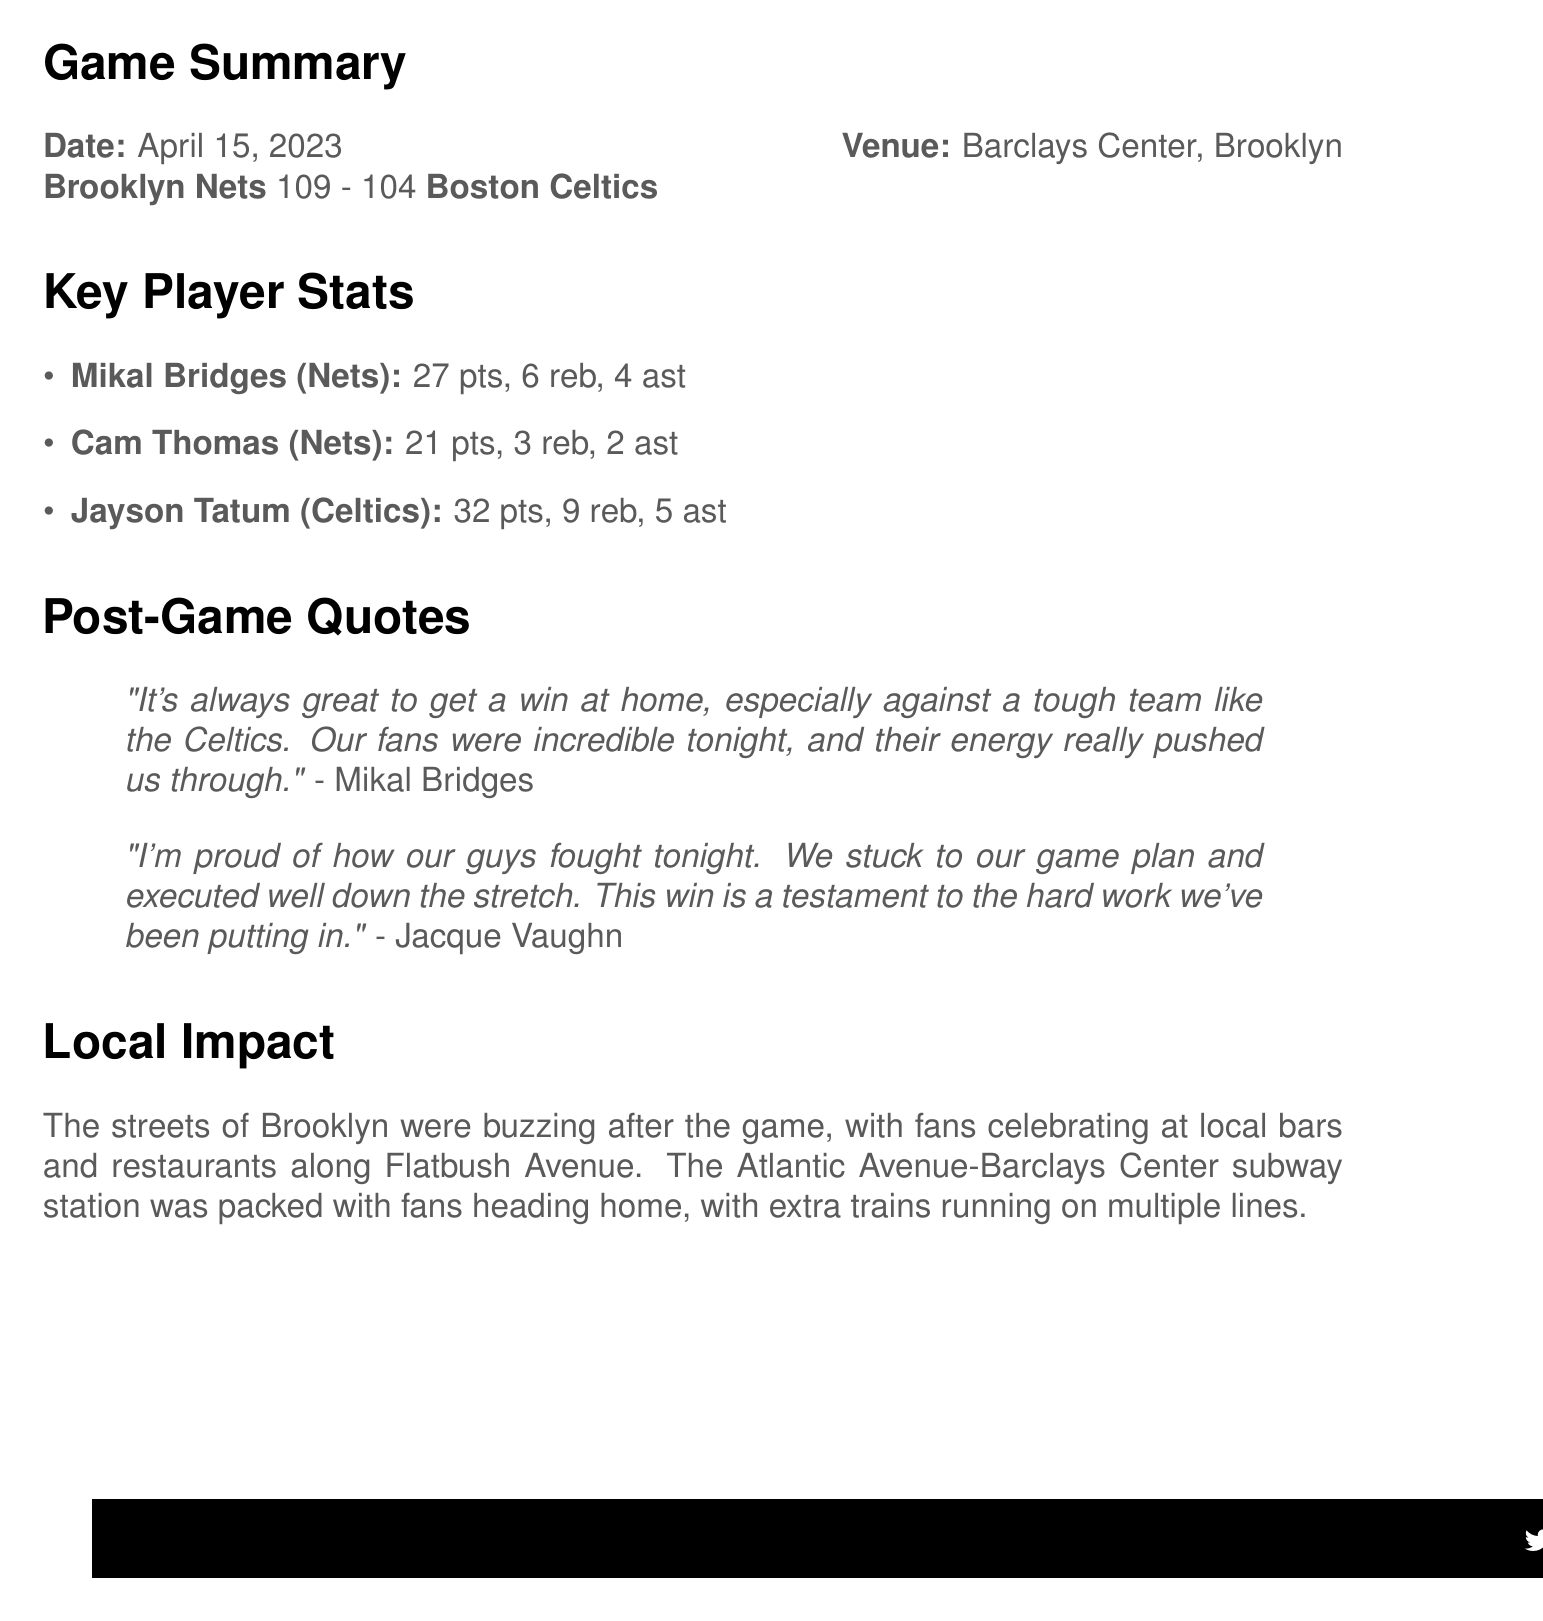What was the final score of the game? The final score is stated in the game summary section as the points scored by each team.
Answer: 109 - 104 Who scored the most points in the game? The key player stats list the points scored by each player, where the highest score needs to be identified.
Answer: Jayson Tatum When did the game take place? The game date is provided in the game summary section.
Answer: April 15, 2023 How many rebounds did Mikal Bridges have? Mikal Bridges' rebounding stats are included in the key player stats section.
Answer: 6 What did Mikal Bridges say after the game? Mikal Bridges' quote is noted in the post-game quotes section.
Answer: "It's always great to get a win at home, especially against a tough team like the Celtics. Our fans were incredible tonight, and their energy really pushed us through." Which team is the next opponent for the Brooklyn Nets? The upcoming game information specifies the opponent for the next home game.
Answer: Philadelphia 76ers How many points did Cam Thomas score? This information is located in the key player stats section under his name.
Answer: 21 What is the location of the Nets Basketball Clinic? The community event details indicate where it will take place.
Answer: Brooklyn Bridge Park How did fans react after the game? The local context describes the fan reaction following the game.
Answer: Celebrating at local bars and restaurants along Flatbush Avenue 